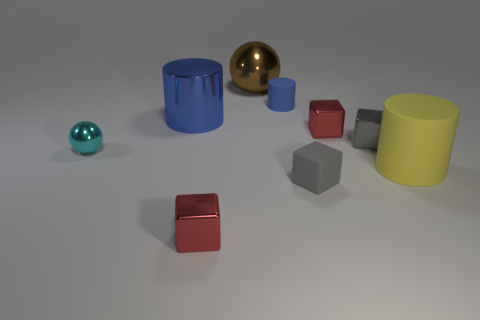Is the number of metal cubes that are in front of the small metal sphere the same as the number of small objects on the left side of the small gray metal cube?
Provide a succinct answer. No. The red metallic object that is behind the cube in front of the small rubber block is what shape?
Provide a succinct answer. Cube. There is a large yellow thing that is the same shape as the blue shiny thing; what material is it?
Provide a short and direct response. Rubber. There is a cylinder that is the same size as the cyan sphere; what color is it?
Offer a very short reply. Blue. Are there an equal number of big objects that are behind the tiny cyan thing and metal spheres?
Ensure brevity in your answer.  Yes. What is the color of the large thing that is to the left of the red metallic object to the left of the brown shiny thing?
Offer a terse response. Blue. How big is the brown metallic ball behind the blue matte cylinder that is right of the cyan thing?
Provide a succinct answer. Large. The metal block that is the same color as the tiny matte cube is what size?
Your answer should be very brief. Small. How many other things are the same size as the brown metal ball?
Your response must be concise. 2. The big rubber thing to the right of the shiny sphere that is to the right of the red shiny object that is on the left side of the brown shiny object is what color?
Give a very brief answer. Yellow. 